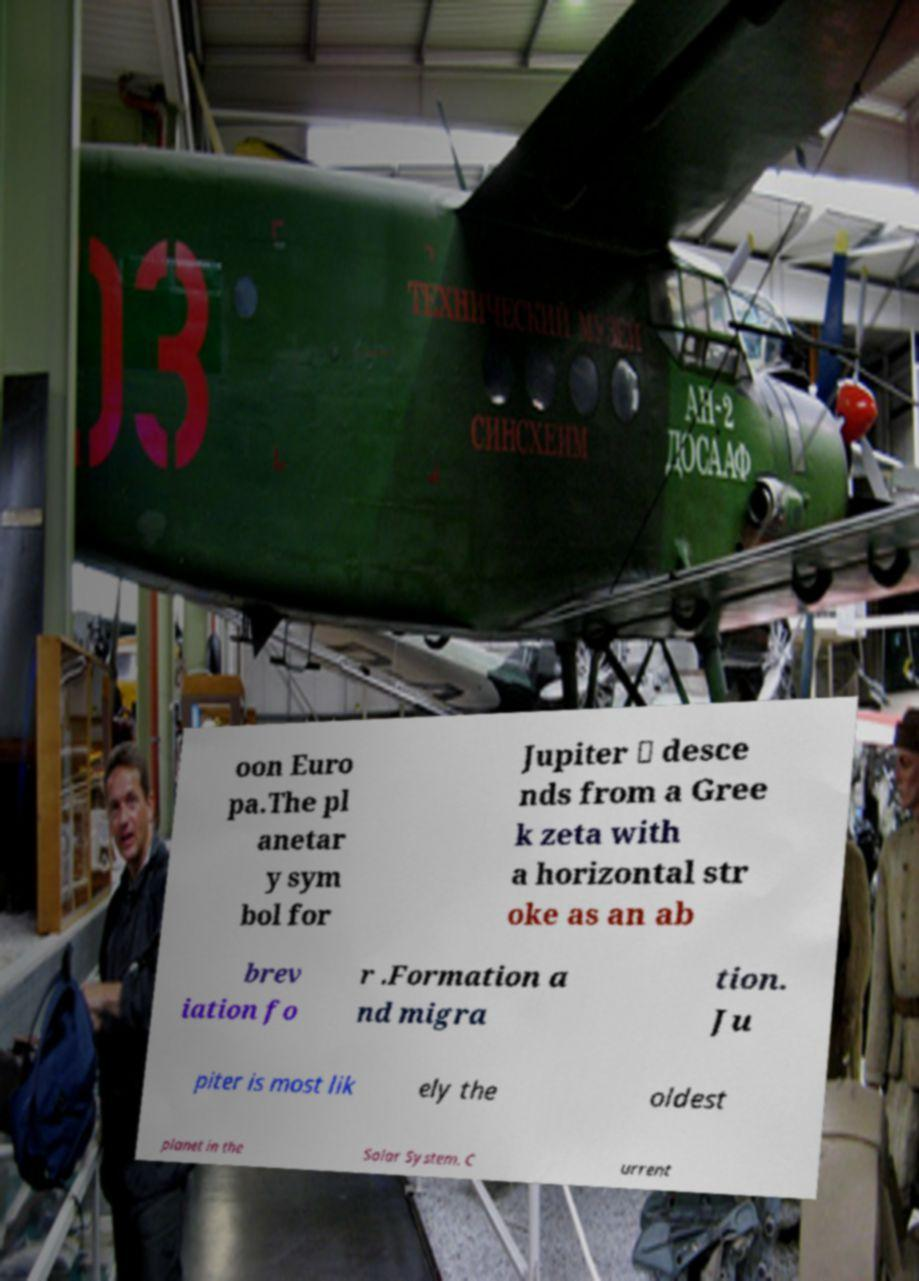What messages or text are displayed in this image? I need them in a readable, typed format. oon Euro pa.The pl anetar y sym bol for Jupiter ♃ desce nds from a Gree k zeta with a horizontal str oke as an ab brev iation fo r .Formation a nd migra tion. Ju piter is most lik ely the oldest planet in the Solar System. C urrent 